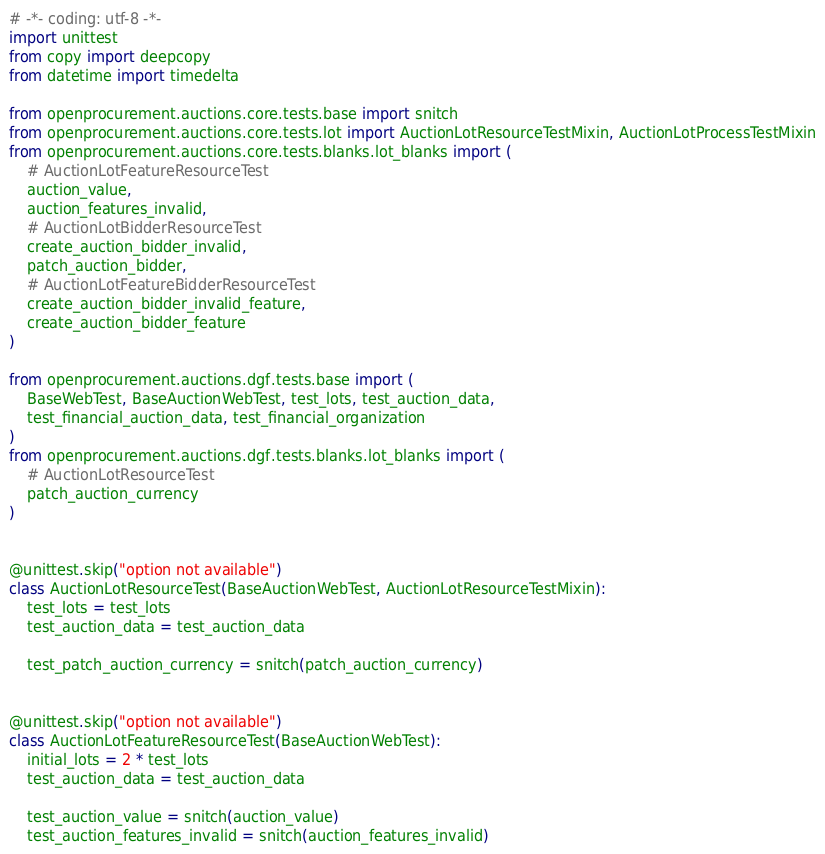<code> <loc_0><loc_0><loc_500><loc_500><_Python_># -*- coding: utf-8 -*-
import unittest
from copy import deepcopy
from datetime import timedelta

from openprocurement.auctions.core.tests.base import snitch
from openprocurement.auctions.core.tests.lot import AuctionLotResourceTestMixin, AuctionLotProcessTestMixin
from openprocurement.auctions.core.tests.blanks.lot_blanks import (
    # AuctionLotFeatureResourceTest
    auction_value,
    auction_features_invalid,
    # AuctionLotBidderResourceTest
    create_auction_bidder_invalid,
    patch_auction_bidder,
    # AuctionLotFeatureBidderResourceTest
    create_auction_bidder_invalid_feature,
    create_auction_bidder_feature
)

from openprocurement.auctions.dgf.tests.base import (
    BaseWebTest, BaseAuctionWebTest, test_lots, test_auction_data,
    test_financial_auction_data, test_financial_organization
)
from openprocurement.auctions.dgf.tests.blanks.lot_blanks import (
    # AuctionLotResourceTest
    patch_auction_currency
)


@unittest.skip("option not available")
class AuctionLotResourceTest(BaseAuctionWebTest, AuctionLotResourceTestMixin):
    test_lots = test_lots
    test_auction_data = test_auction_data

    test_patch_auction_currency = snitch(patch_auction_currency)


@unittest.skip("option not available")
class AuctionLotFeatureResourceTest(BaseAuctionWebTest):
    initial_lots = 2 * test_lots
    test_auction_data = test_auction_data

    test_auction_value = snitch(auction_value)
    test_auction_features_invalid = snitch(auction_features_invalid)

</code> 